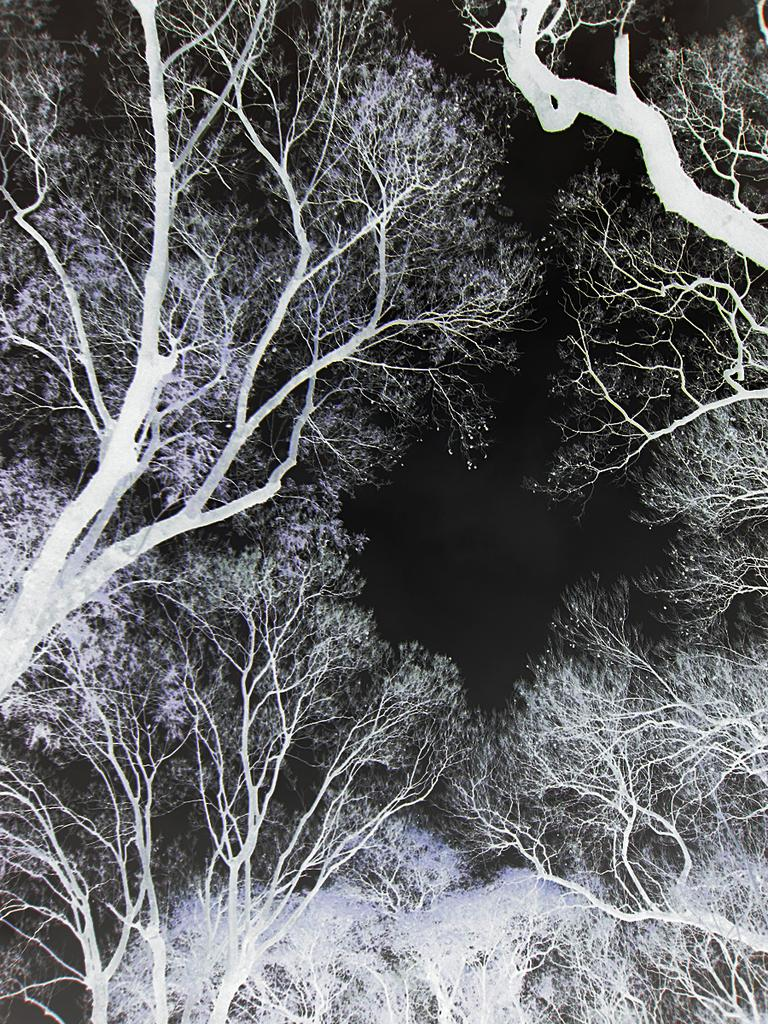What type of vegetation can be seen in the image? There are trees in the image. What color scheme is used in the image? The image is in black and white color. What part of the natural environment is visible in the image? The sky is visible in the image. What time of day is depicted in the image? The image is set during night time. How many doors can be seen in the image? There are no doors present in the image. What type of animals can be seen hopping around in the image? There are no animals, such as frogs, present in the image. 